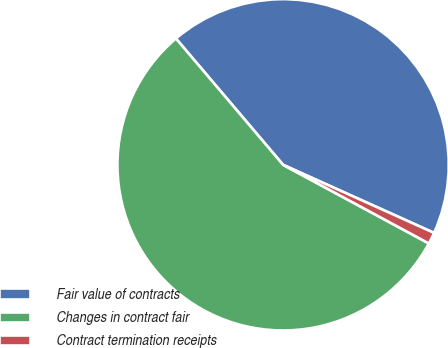<chart> <loc_0><loc_0><loc_500><loc_500><pie_chart><fcel>Fair value of contracts<fcel>Changes in contract fair<fcel>Contract termination receipts<nl><fcel>42.94%<fcel>55.93%<fcel>1.13%<nl></chart> 